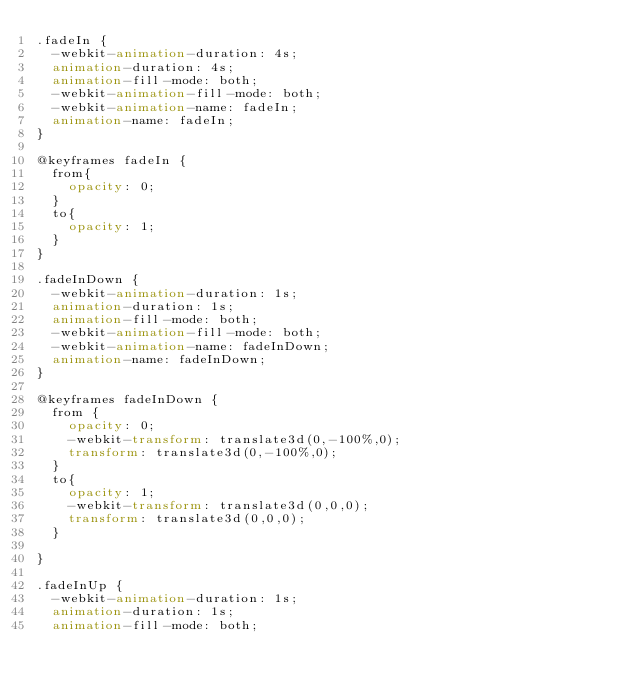<code> <loc_0><loc_0><loc_500><loc_500><_CSS_>.fadeIn {
  -webkit-animation-duration: 4s;
  animation-duration: 4s;
  animation-fill-mode: both;
  -webkit-animation-fill-mode: both;
  -webkit-animation-name: fadeIn;
  animation-name: fadeIn;
}

@keyframes fadeIn {
  from{
    opacity: 0;
  }
  to{
    opacity: 1;
  }
}

.fadeInDown {
  -webkit-animation-duration: 1s;
  animation-duration: 1s;
  animation-fill-mode: both;
  -webkit-animation-fill-mode: both;
  -webkit-animation-name: fadeInDown;
  animation-name: fadeInDown;
}

@keyframes fadeInDown {
  from {
    opacity: 0;
    -webkit-transform: translate3d(0,-100%,0);
    transform: translate3d(0,-100%,0);
  }
  to{
    opacity: 1;
    -webkit-transform: translate3d(0,0,0);
    transform: translate3d(0,0,0);
  }

}

.fadeInUp {
  -webkit-animation-duration: 1s;
  animation-duration: 1s;
  animation-fill-mode: both;</code> 